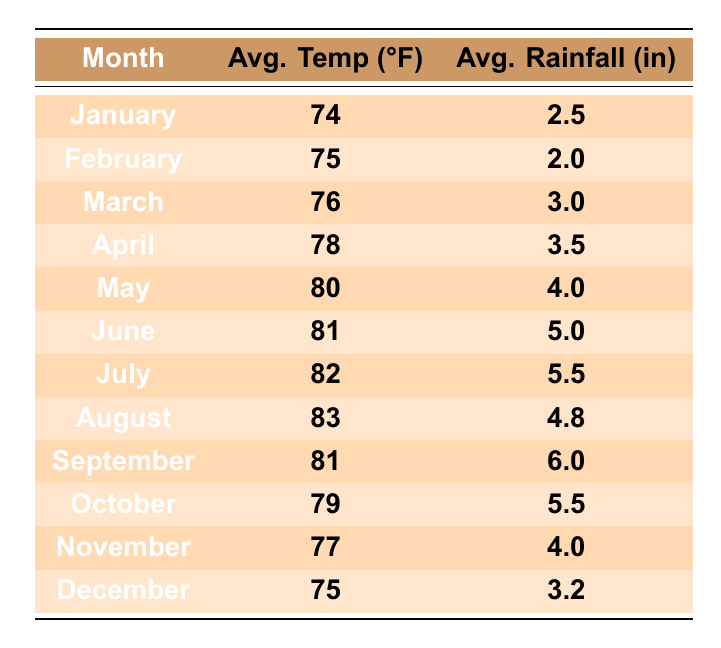What is the average temperature in July? From the table, the average temperature for July is listed under the Avg. Temp column, which shows 82°F.
Answer: 82°F How much rainfall is typically recorded in March? Looking at the table, the average rainfall for March can be found in the Avg. Rainfall column, which shows 3.0 inches.
Answer: 3.0 inches Which month has the highest average temperature? The month with the highest temperature can be identified by scanning the Avg. Temp column; August has the highest at 83°F.
Answer: August What is the average rainfall in the first half of the year (January to June)? To find the average, add the rainfall from January (2.5), February (2.0), March (3.0), April (3.5), May (4.0), and June (5.0). The total is 20.0 inches; dividing by 6 gives an average of about 3.33 inches.
Answer: 3.33 inches During which months does Santa Isabel receive more than 5 inches of rainfall? By reviewing the Avg. Rainfall column, June (5.0), July (5.5), September (6.0), and October (5.5) are the months exceeding 5 inches.
Answer: June, July, September, October What is the difference in average temperature between January and December? The average temperature for January is 74°F and for December is 75°F. The difference is calculated as 75 - 74 = 1°F.
Answer: 1°F Is it true that the average rainfall in April is higher than in February? Comparing the Avg. Rainfall values, April (3.5 inches) is higher than February (2.0 inches), confirming the statement.
Answer: Yes Calculate the total average rainfall for the entire year. To find the total, add all the monthly rainfall values: 2.5 + 2.0 + 3.0 + 3.5 + 4.0 + 5.0 + 5.5 + 4.8 + 6.0 + 5.5 + 4.0 + 3.2 = 54.0 inches.
Answer: 54.0 inches Which month has the lowest average rainfall? By checking the Avg. Rainfall column, February has the lowest at 2.0 inches.
Answer: February Are the average temperatures in October and November higher than 75°F? October has an average temperature of 79°F and November has 77°F, both are higher than 75°F. Therefore, the statement is true.
Answer: Yes 